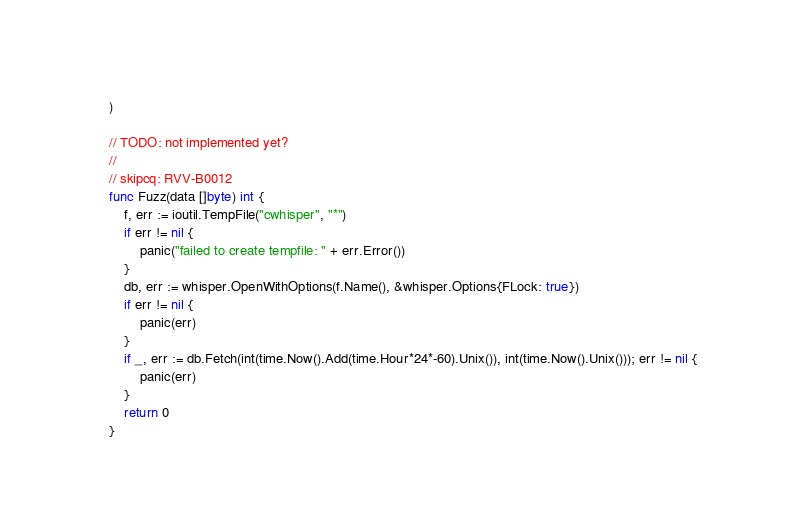<code> <loc_0><loc_0><loc_500><loc_500><_Go_>)

// TODO: not implemented yet?
//
// skipcq: RVV-B0012
func Fuzz(data []byte) int {
	f, err := ioutil.TempFile("cwhisper", "*")
	if err != nil {
		panic("failed to create tempfile: " + err.Error())
	}
	db, err := whisper.OpenWithOptions(f.Name(), &whisper.Options{FLock: true})
	if err != nil {
		panic(err)
	}
	if _, err := db.Fetch(int(time.Now().Add(time.Hour*24*-60).Unix()), int(time.Now().Unix())); err != nil {
		panic(err)
	}
	return 0
}
</code> 